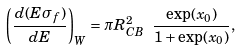<formula> <loc_0><loc_0><loc_500><loc_500>\left ( \frac { d ( E \sigma _ { f } ) } { d E } \right ) _ { W } = \pi R _ { C B } ^ { 2 } \ \frac { \exp ( x _ { 0 } ) } { 1 + \exp ( x _ { 0 } ) } ,</formula> 